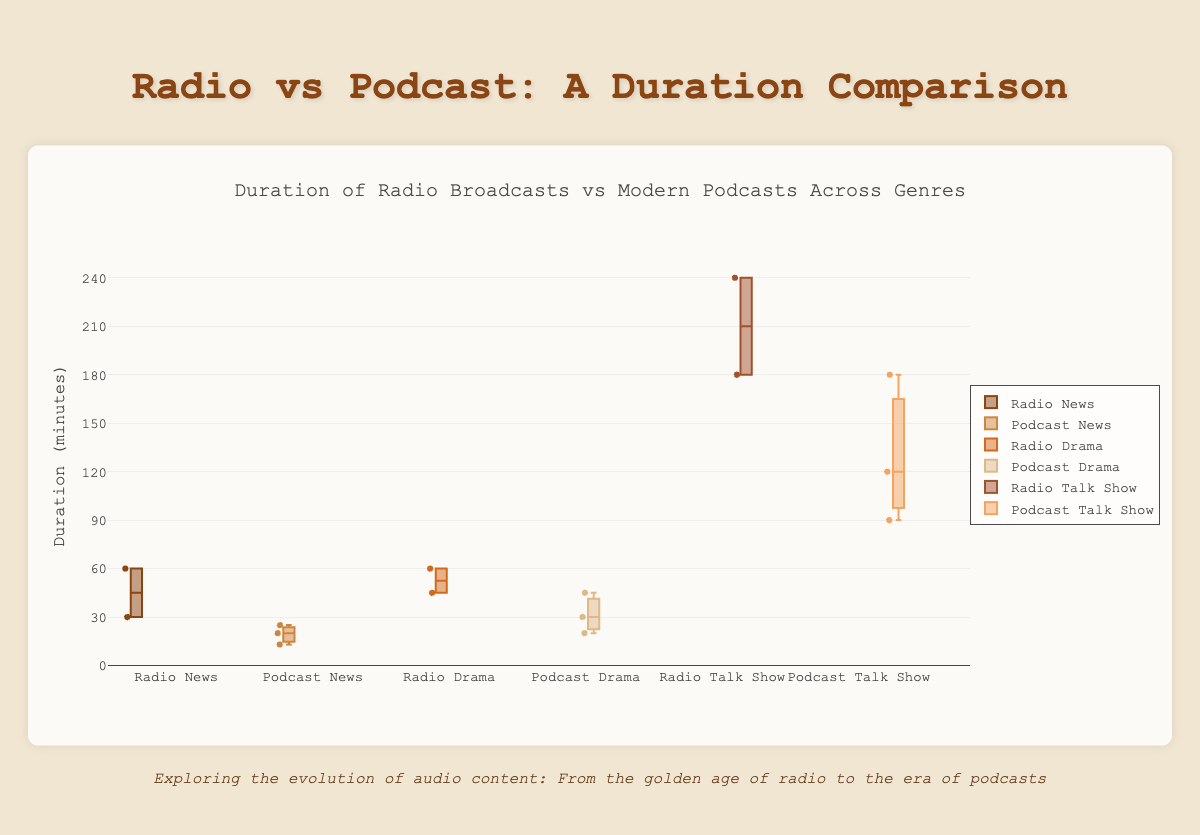What is the maximum duration for a Talk Show podcast? The pod for Talk Shows lists The Joe Rogan Experience with a duration of 180 minutes.
Answer: 180 Which has a higher median duration: Radio News or Podcast News? The median of Radio News is 45 (average of 30 and 60), while the median of Podcast News is 20.
Answer: Radio News What is the interquartile range (IQR) for Drama podcasts? The durations for Drama podcasts are 20, 30, and 45. The 1st quartile (Q1) is 25 and the 3rd quartile (Q3) is 45, thus the IQR is Q3 - Q1 = 45 - 25 = 20 minutes.
Answer: 20 minutes Which genre has the widest range of durations for radio broadcasts? From the box plots, Talk Show radio has the widest range (The Howard Stern Show at 240 minutes and The Rush Limbaugh Show at 180 minutes, giving a range of 240 - 180 = 60 minutes).
Answer: Talk Show What is the median duration for Drama radio broadcasts? The durations for Drama radio are 60 and 45. The median is the average of these two values: (60 + 45) / 2 = 52.5 minutes.
Answer: 52.5 What is the maximum duration for news-related audio content, comparing both radio and podcasts? The maximum duration for News in radio is from NPR News at 60 minutes, while the Podcast maximum is The Daily at 25 minutes. Comparing both, NPR News in Radio is longer.
Answer: 60 Are the durations more varied in Drama radio or Drama podcasts? The box plots for Drama radio and Drama podcasts both have roughly equal ranges, but Drama radio has a maximum of 60 and minimum of 45, while Drama podcasts range from 20 to 45, indicating more variation in podcasts.
Answer: Drama podcasts Which type of Talk Show (Radio or Podcast) has the greater variability in durations? The durations for Radio Talk Shows range from 180 to 240, while Podcast Talk Shows range from 90 to 180, indicating that Radio Talk Shows have a greater variability.
Answer: Radio Talk Shows 